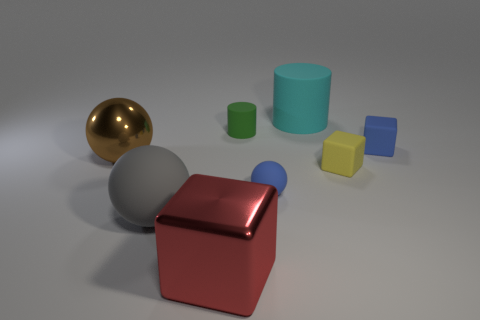Subtract all gray matte balls. How many balls are left? 2 Subtract all blue blocks. How many blocks are left? 2 Subtract 1 cylinders. How many cylinders are left? 1 Add 2 red metal things. How many objects exist? 10 Subtract all cubes. How many objects are left? 5 Subtract all green blocks. Subtract all yellow spheres. How many blocks are left? 3 Subtract all big matte objects. Subtract all cyan things. How many objects are left? 5 Add 1 large matte objects. How many large matte objects are left? 3 Add 8 blue blocks. How many blue blocks exist? 9 Subtract 0 green blocks. How many objects are left? 8 